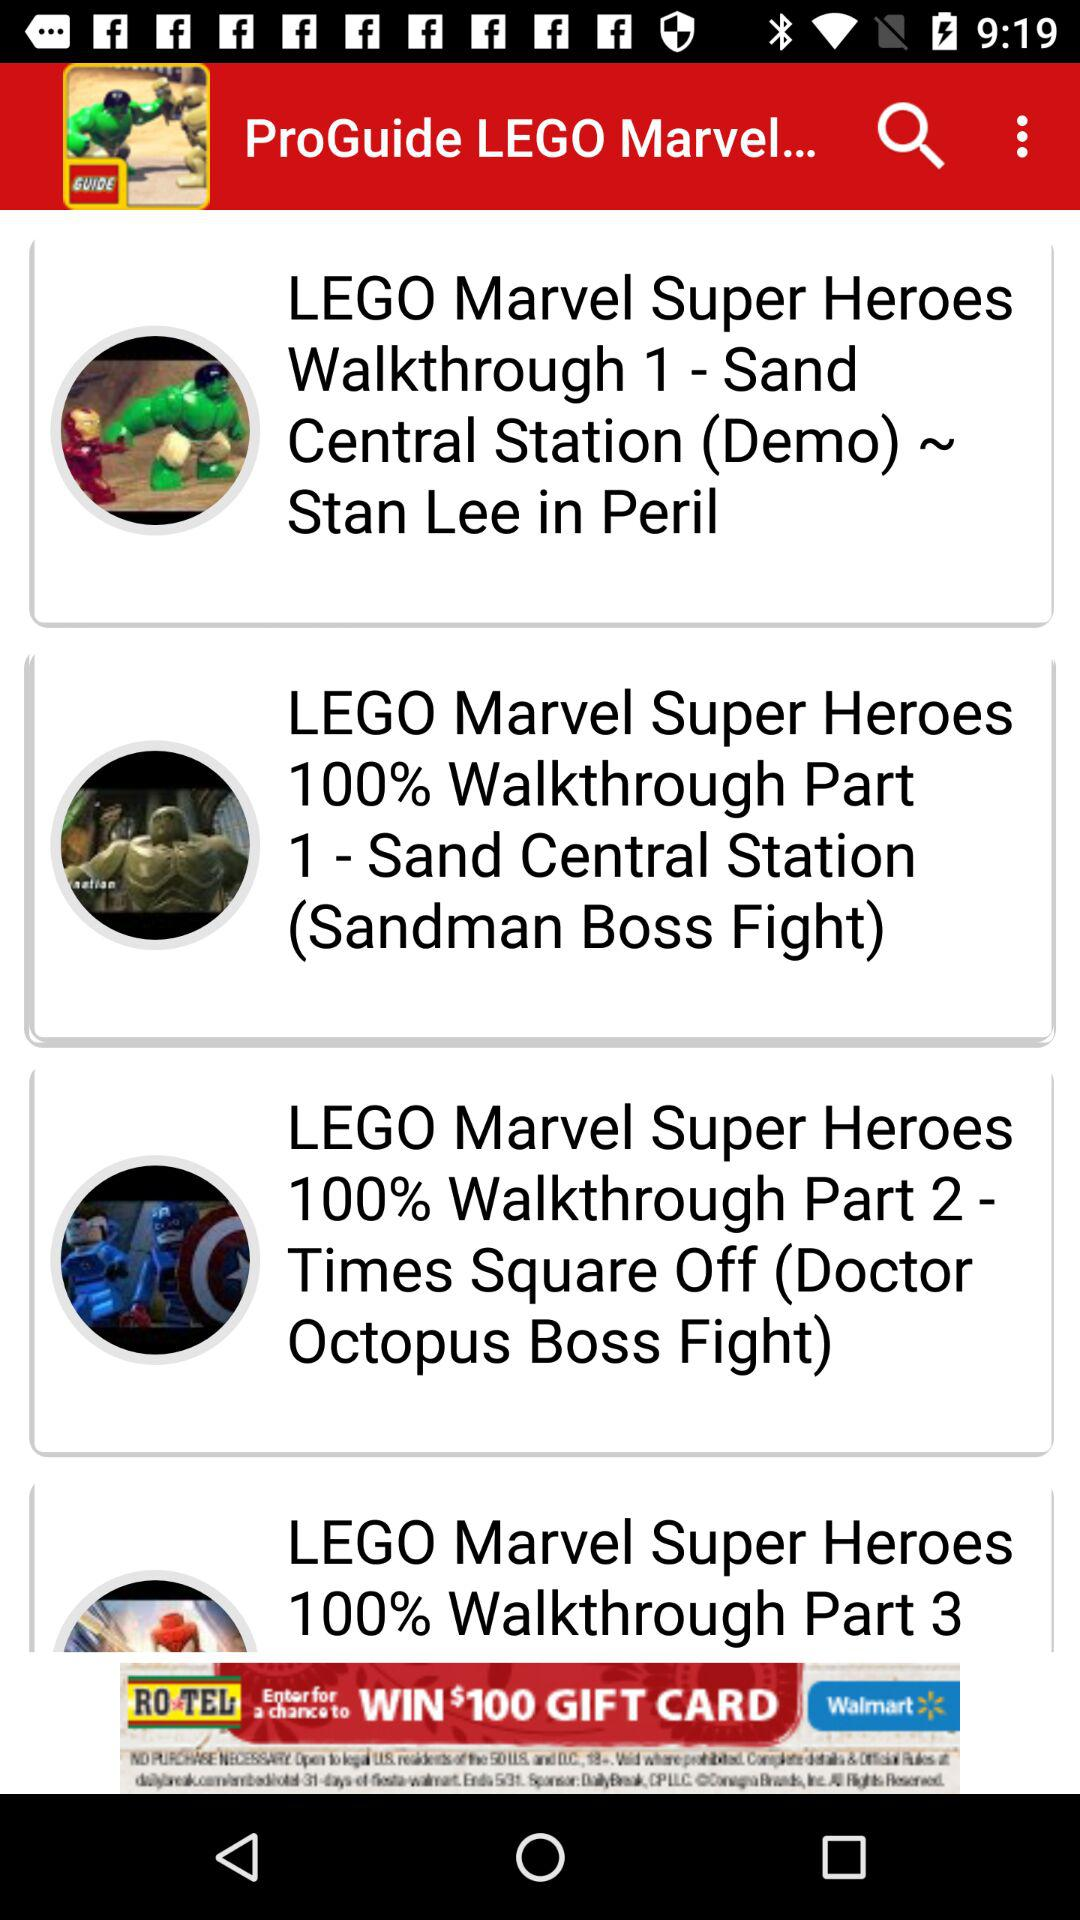How many walkthrough parts are there for LEGO Marvel Super Heroes?
Answer the question using a single word or phrase. 3 